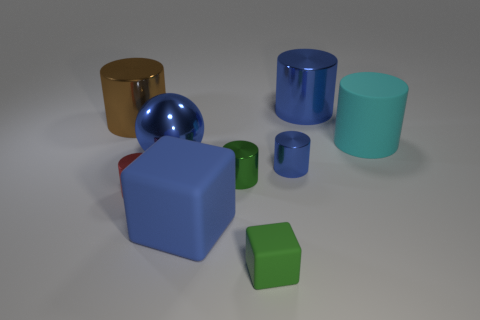Subtract all purple balls. How many blue cylinders are left? 2 Subtract all large cyan cylinders. How many cylinders are left? 5 Subtract 3 cylinders. How many cylinders are left? 3 Subtract all brown cylinders. How many cylinders are left? 5 Add 1 large blue things. How many objects exist? 10 Subtract all green cylinders. Subtract all brown blocks. How many cylinders are left? 5 Subtract 1 cyan cylinders. How many objects are left? 8 Subtract all cylinders. How many objects are left? 3 Subtract all big shiny cylinders. Subtract all red metallic cylinders. How many objects are left? 6 Add 9 shiny spheres. How many shiny spheres are left? 10 